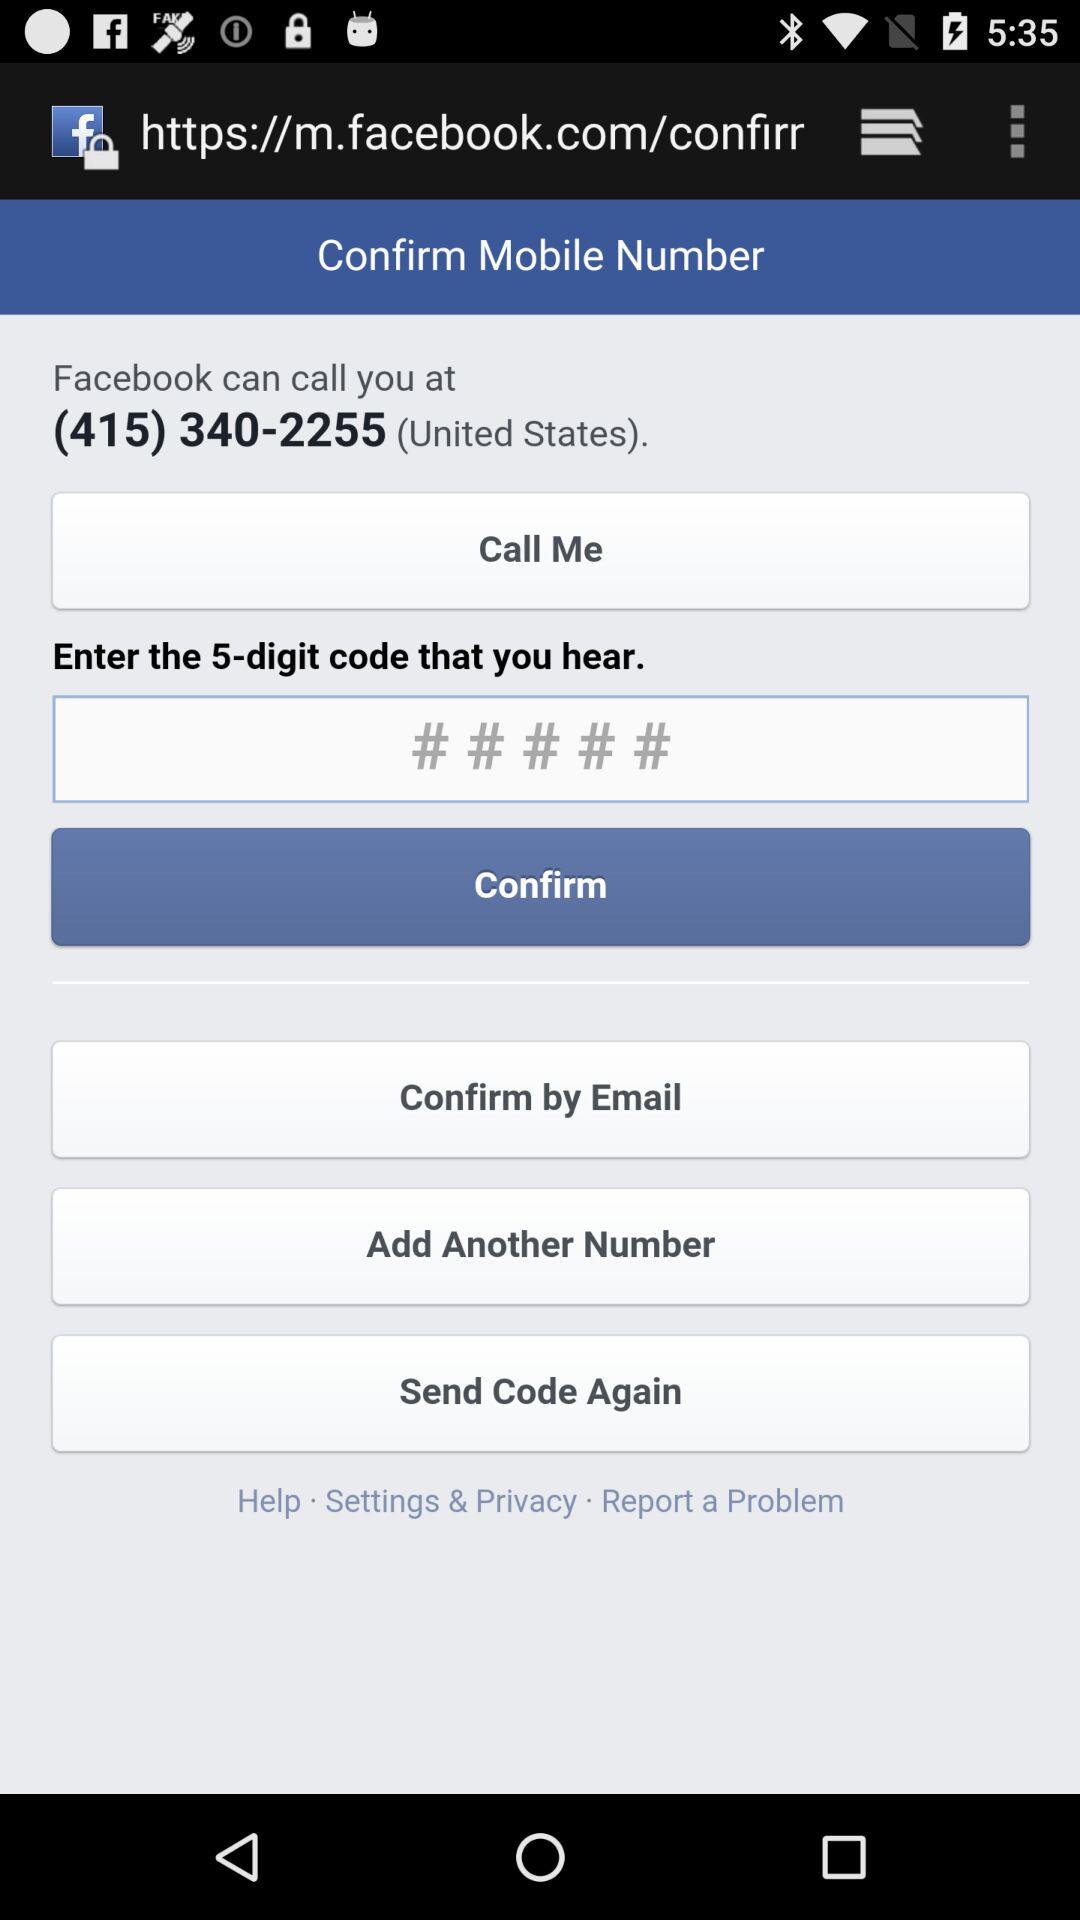How many digits are in the code that I need to enter?
Answer the question using a single word or phrase. 5 